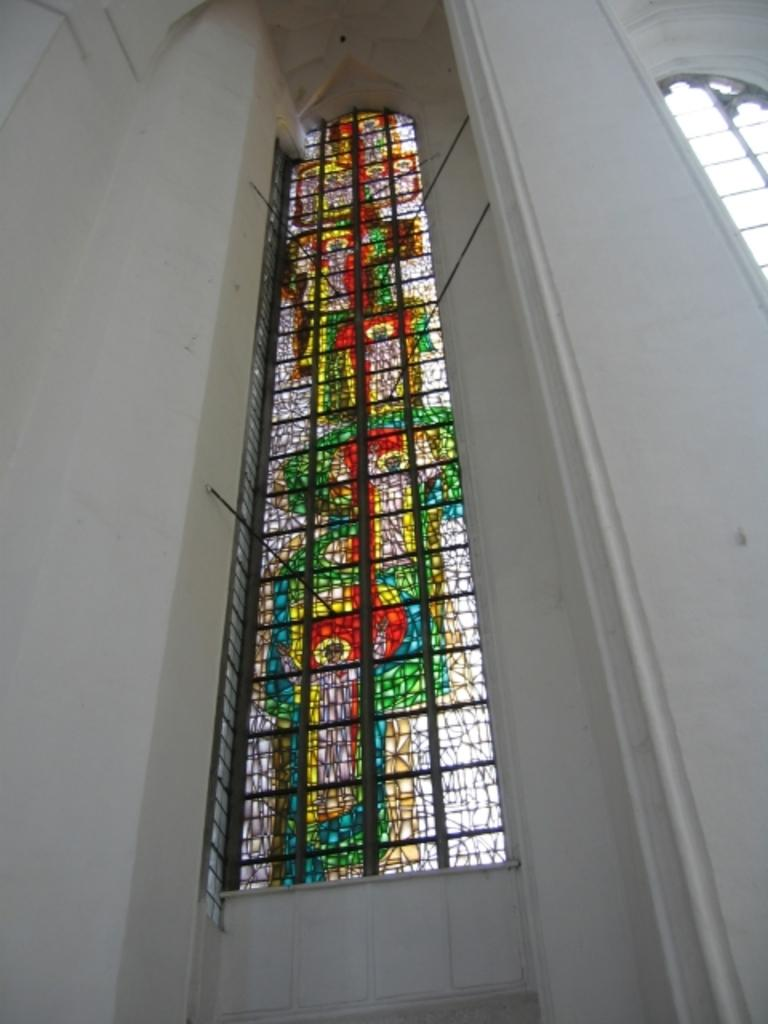What type of wall is visible in the image? There is a white wall in the image. What can be seen on the wall? There are windows in the image. How many windows are there, and what is unique about one of them? There are multiple windows, and one of them is colorful. What is attached to the windows? There are rods on the window. What is the distance between the wall and the market in the image? There is no mention of a market in the image. --- Facts: 1. There is a person in the image. 2. The person is wearing a hat. 3. The person is holding a book. 4. There is a table in the image. 5. The table has a vase with flowers on it. Absurd Topics: elephant, ocean, parrot Conversation: Who or what is in the image? There is a person in the image. What is the person wearing in the image? The person is wearing a hat in the image. What is the person holding in the image? The person is holding a book in the image. What is on the table in the image? There is a vase with flowers on the table in the image. Reasoning: Let's think step by step in order to produce the conversation. We start by identifying the main subject in the image, which is the person. Then, we describe the person's attire and what they are holding. Finally, we observe the objects on the table. Each question is designed to elicit a specific detail about the image that is known from the provided facts. Absurd Question/Answer: Can you hear the parrot squawking in the image? There is no mention of a parrot in the image. --- Facts: 1. There is a dog in the image. 2. The dog is sitting on a chair. 3. The dog is wearing a bow tie. 4. There is a person standing next to the chair. 5. The person is holding a leash. Absurd Topics: horse Conversation: What type of animal is in the image? There is a dog in the image. What is the dog doing in the image? The dog is sitting on a chair in the image. What is the dog wearing in the image? The dog is wearing a bow tie in the image. What is the person doing in the image? There is a person standing next to the chair in the image. What is the person holding in the image? The person is holding a leash in the image. Reasoning: Let's think step by step in order to produce the conversation. We start by identifying the main subject in the image, which is the dog. Then, we describe the dog's actions and what they are wearing. Next, 